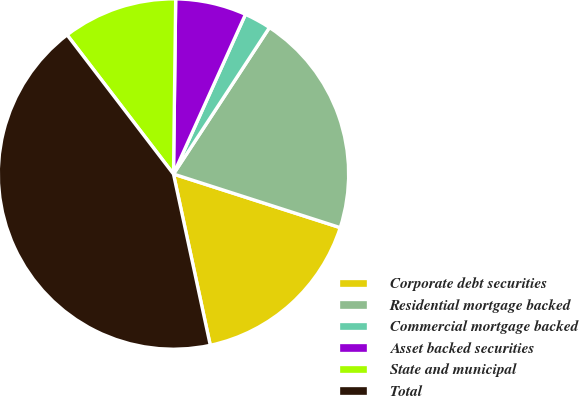<chart> <loc_0><loc_0><loc_500><loc_500><pie_chart><fcel>Corporate debt securities<fcel>Residential mortgage backed<fcel>Commercial mortgage backed<fcel>Asset backed securities<fcel>State and municipal<fcel>Total<nl><fcel>16.68%<fcel>20.72%<fcel>2.49%<fcel>6.54%<fcel>10.59%<fcel>42.98%<nl></chart> 